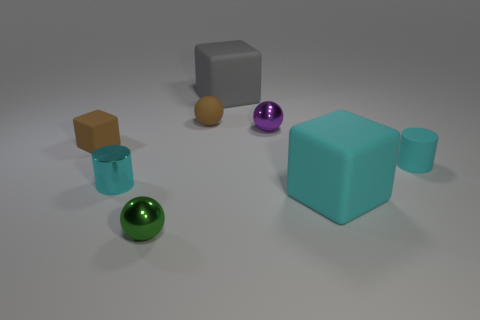Subtract all cyan blocks. How many blocks are left? 2 Add 2 small blue spheres. How many objects exist? 10 Subtract all green balls. How many balls are left? 2 Subtract 1 blocks. How many blocks are left? 2 Subtract all cylinders. How many objects are left? 6 Add 3 tiny matte balls. How many tiny matte balls exist? 4 Subtract 1 brown blocks. How many objects are left? 7 Subtract all red cylinders. Subtract all cyan blocks. How many cylinders are left? 2 Subtract all small things. Subtract all purple metal things. How many objects are left? 1 Add 3 small cyan cylinders. How many small cyan cylinders are left? 5 